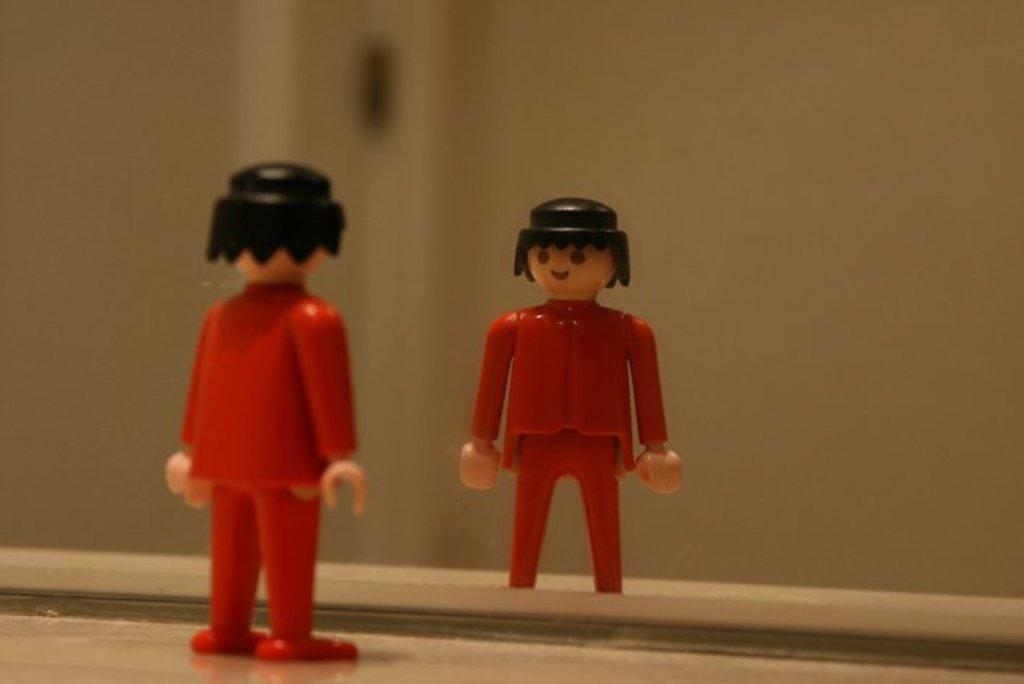What object can be seen in the image? There is a toy in the image. Where is the toy located? The toy is on a surface. What can be seen in the mirror in the image? The reflection of the toy and the reflection of the wall are visible in the mirror. What type of nation is being celebrated at the party in the image? There is no party or nation present in the image; it features a toy on a surface with its reflection in a mirror. 